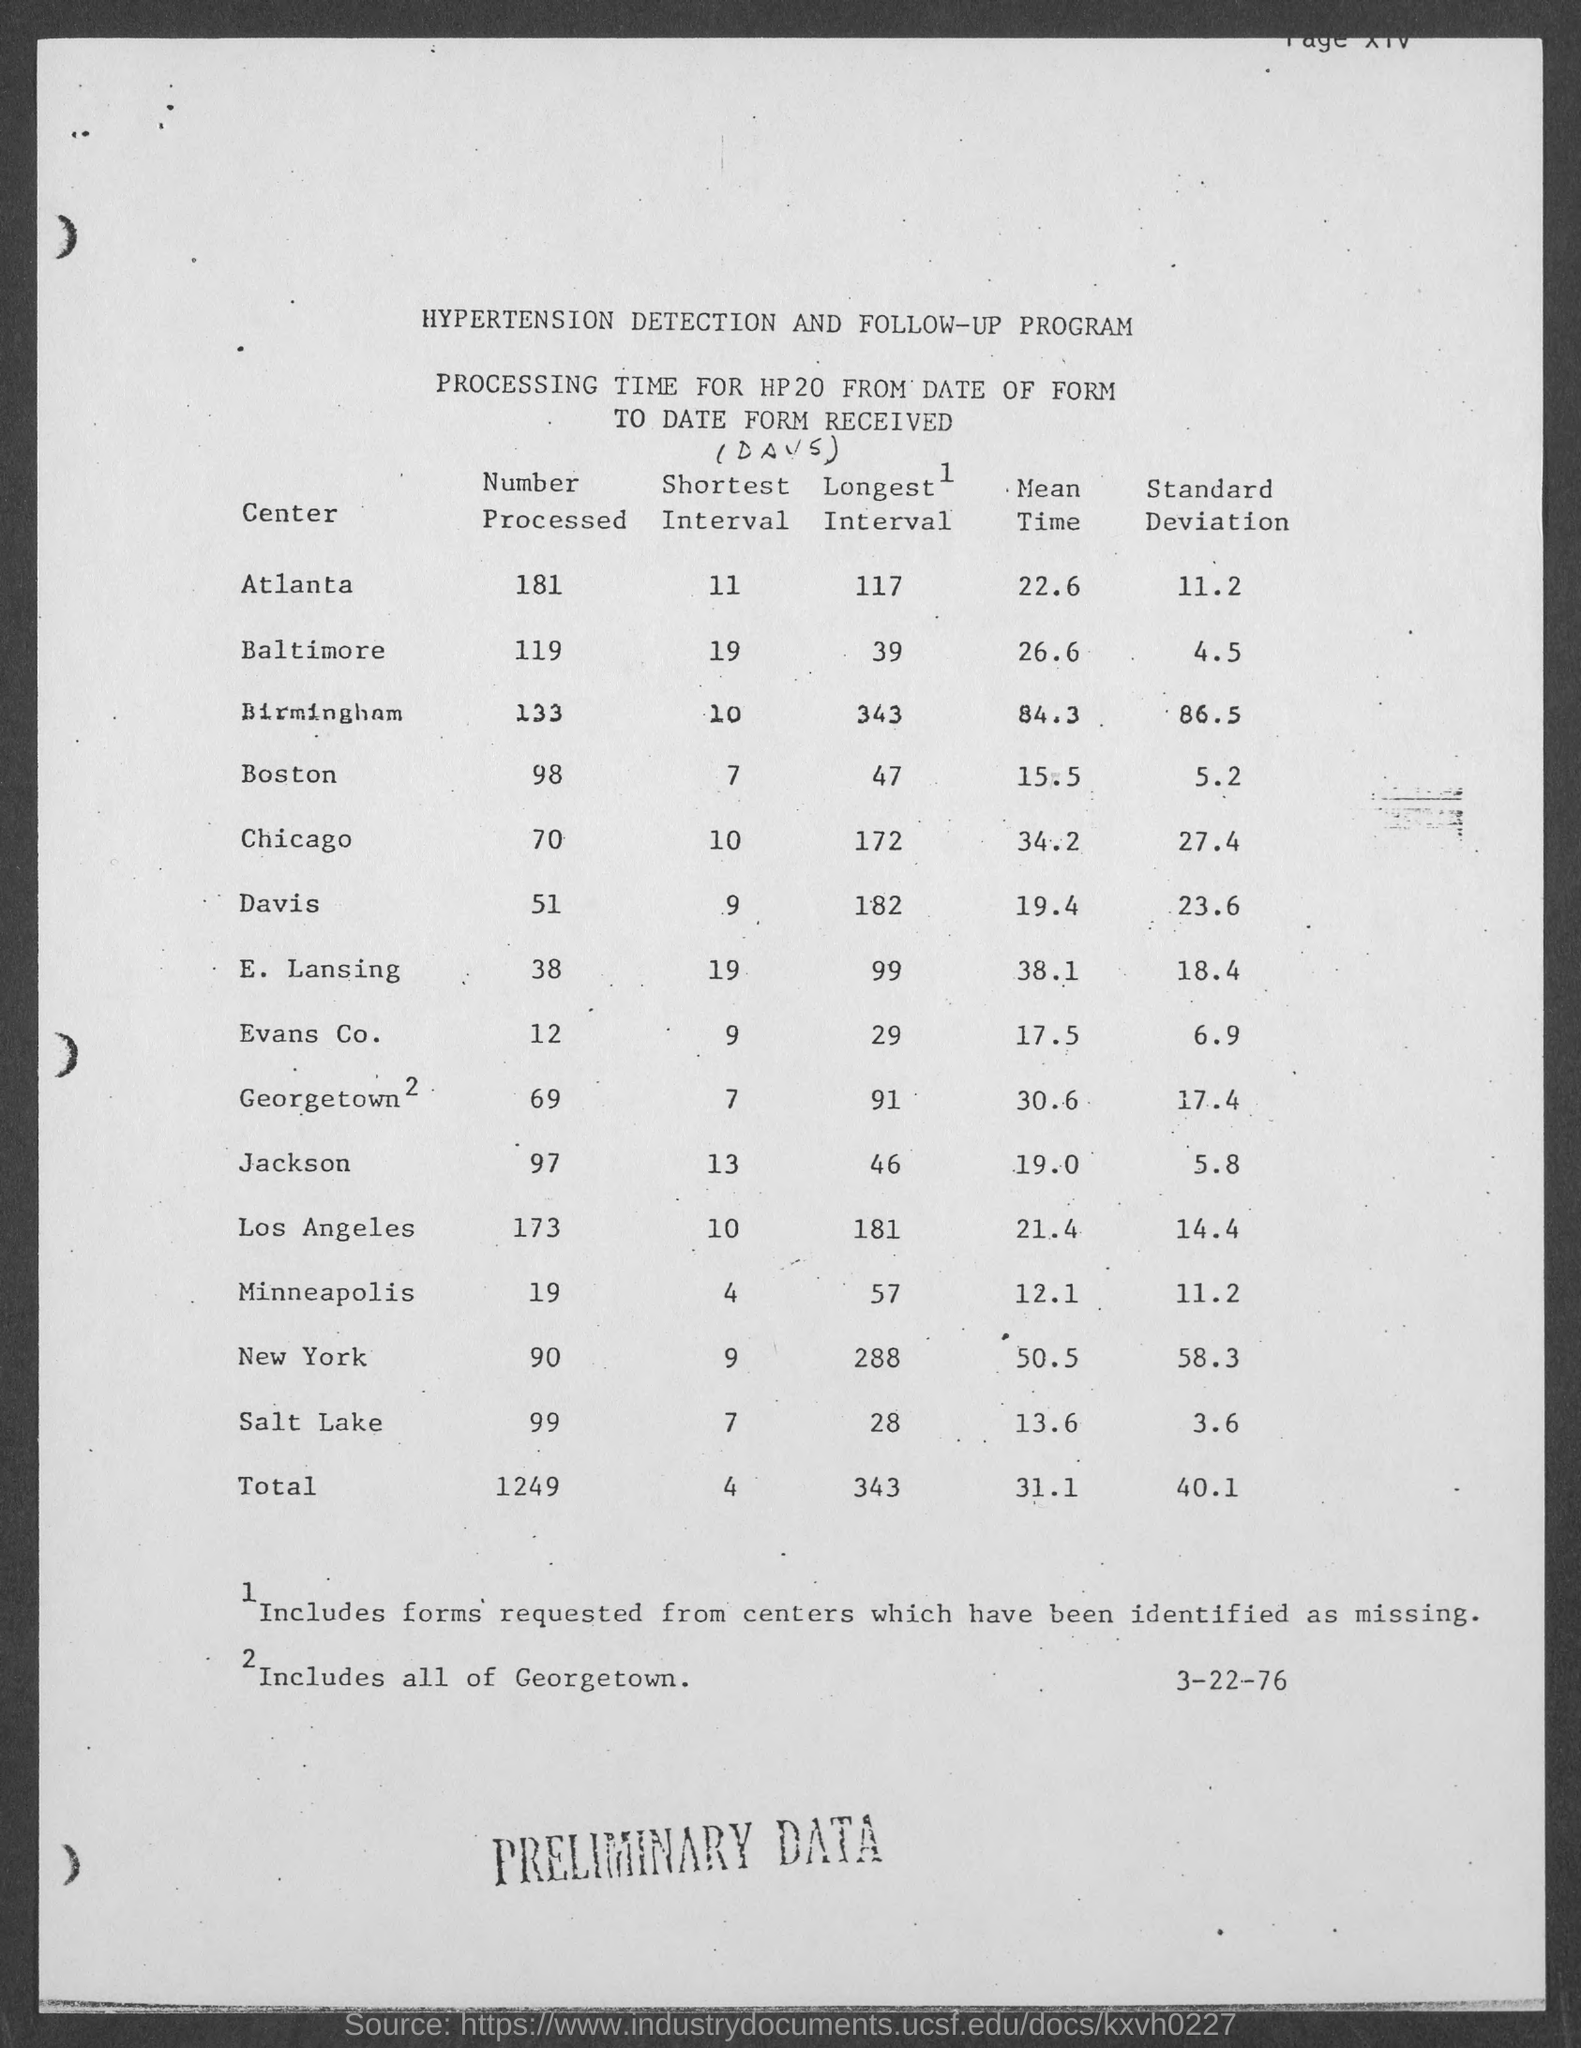What is the number of processed form from Atlanta?
Provide a short and direct response. 181. What is the standard deviation mentioned in the centre Baltimore?
Ensure brevity in your answer.  4.5. What is the number mentioned in the bottom right of the page?
Ensure brevity in your answer.  3-22-76. What is the total number of processed forms received?
Provide a short and direct response. 1249. What was written at the bottom of the page in capital letters?
Offer a very short reply. PRELIMINARY DATA. 